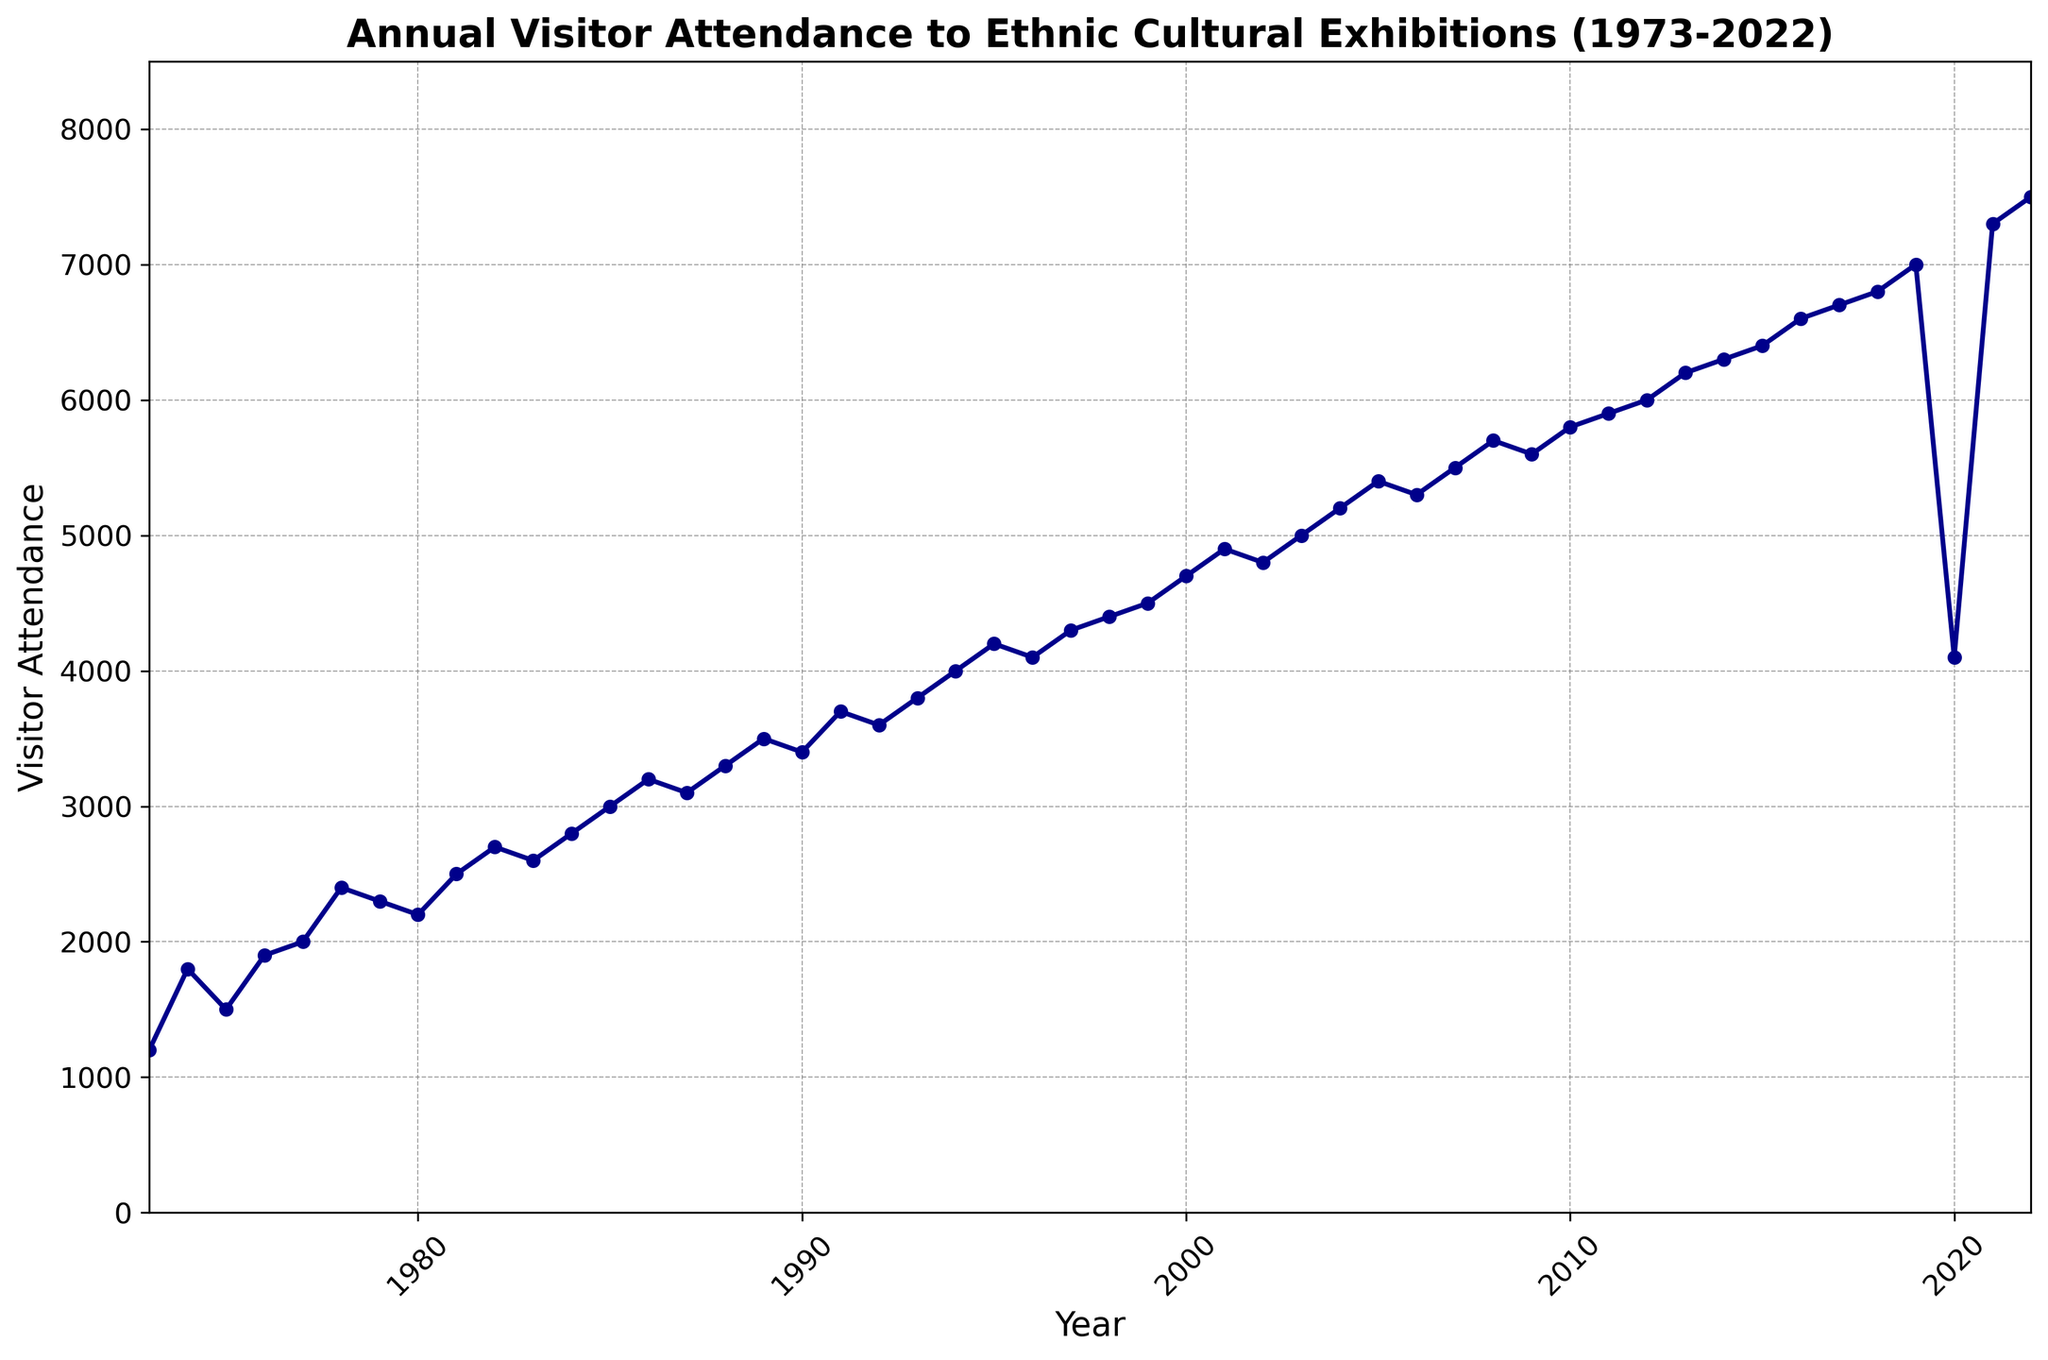What was the visitor attendance in 1985? Look for the visitor attendance data point at the year 1985 in the plot.
Answer: 3000 Which year had higher visitor attendance, 1990 or 2022? Compare the visitor attendance for 1990 and 2022 from their respective data points in the plot.
Answer: 2022 What is the average visitor attendance from 1973 to 1983? Sum the visitor attendance for each year from 1973 to 1983, then divide by the number of years (11). (1200 + 1800 + 1500 + 1900 + 2000 + 2400 + 2300 + 2200 + 2500 + 2700 + 2600) / 11 = 21136 / 11 = 1980
Answer: 1980 In which year did visitor attendance surpass 5000 for the first time? Identify the first year in the plot where visitor attendance exceeds 5000 by following the trend line.
Answer: 2003 How did visitor attendance change from 2010 to 2020? Subtract the 2010 value from the 2020 value to determine the change. 4100 (2020) - 5800 (2010) = -1700
Answer: It decreased by 1700 What is the highest visitor attendance recorded and in which year? Identify the maximum data point on the plot and note the year it corresponds to.
Answer: 7500 in 2022 How many years did it take for the attendance to grow from 2000 to 4000? Find the years when the attendance was 2000 (1977) and 4000 (1994), then subtract to find the difference. 1994 - 1977 = 17 years
Answer: 17 years Was there any year when the visitor attendance dropped significantly compared to the previous year? Identify if any year on the plot shows a noticeable drop in visitor attendance compared to the previous year, such as from 2019 to 2020.
Answer: 2020 What can you observe about the visitor attendance trend between 2000 and 2010? Observe the general upward or downward movement of the line plot between 2000 and 2010. The plot steadily increases from 4700 (2000) to 5800 (2010), indicating an overall upward trend.
Answer: Steady increase What was the percentage increase in visitor attendance from 2000 to 2019? Calculate the percentage increase using the formula: [(Value in 2019 - Value in 2000) / Value in 2000] * 100. [(7000 - 4700) / 4700] * 100 = 49%.
Answer: 49% 